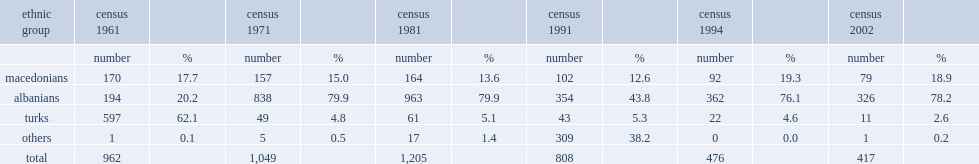How many residents did the grncari have in total? 417.0. 